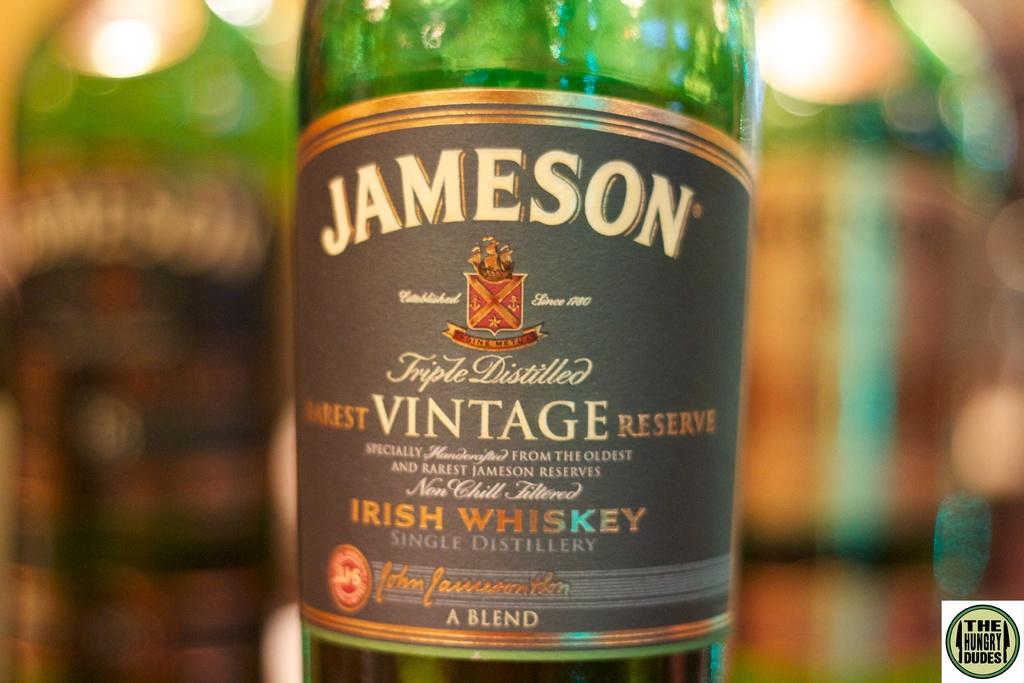What is the name of the whiskey company?
Offer a terse response. Jameson. What country is this whiskey from?
Your answer should be compact. Ireland. 